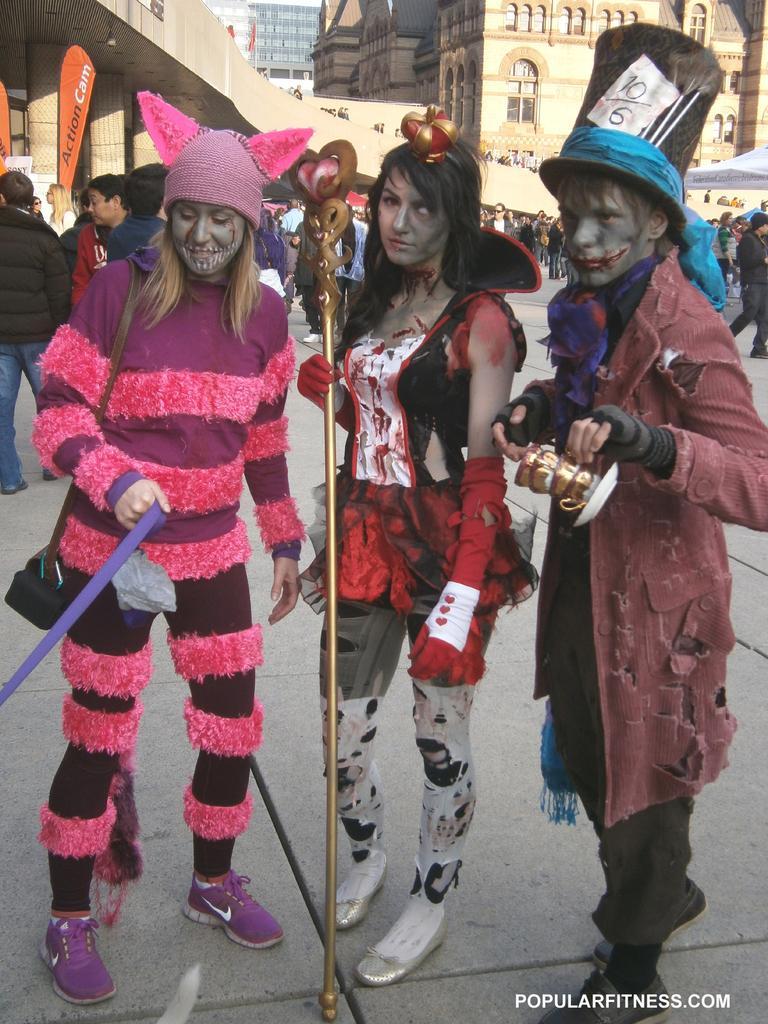Could you give a brief overview of what you see in this image? In the center of the image we can see persons standing on the floor. In the background we can see buildings, persons and road. 